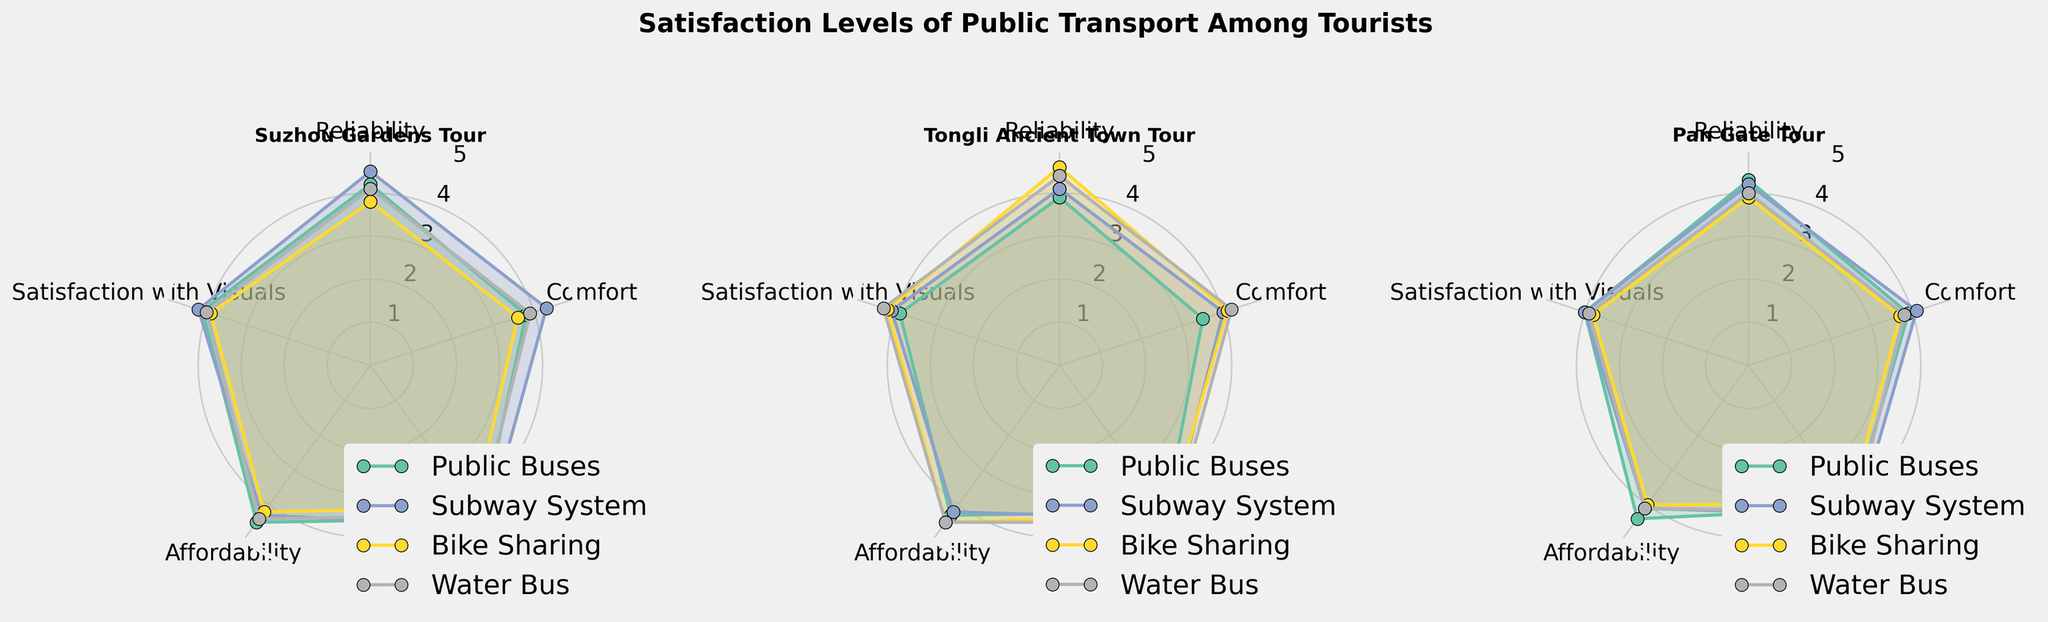What's the title of the figure? The title is displayed at the top of the figure and reads "Satisfaction Levels of Public Transport Among Tourists".
Answer: Satisfaction Levels of Public Transport Among Tourists How many subplots are there and what do they represent? There are three subplots, each representing satisfaction levels for different tours: Suzhou Gardens Tour, Tongli Ancient Town Tour, and Pan Gate Tour.
Answer: Three subplots Which transport mode consistently has the highest satisfaction in the 'Accessibility' category? By looking at the 'Accessibility' ratings in each subplot, the Subway System is consistently rated highest for all tours.
Answer: Subway System Between the Suzhou Gardens Tour and Tongli Ancient Town Tour, which has higher overall satisfaction for 'Water Bus'? Checking the water bus satisfaction values from the subplots for Suzhou Gardens Tour (4.3) and Tongli Ancient Town Tour (4.5), Tongli Ancient Town Tour is higher.
Answer: Tongli Ancient Town Tour What is the lowest satisfaction score across all categories for Pan Gate Tour? By examining all values for Pan Gate Tour, the lowest satisfaction score is for 'Bike Sharing' in 'Satisfaction with Visuals', which is 3.8.
Answer: 3.8 Rank the tours from highest to lowest based on 'Affordability' overall satisfaction. Looking at the overall satisfaction for 'Affordability': Tongli Ancient Town Tour (4.38), Suzhou Gardens Tour (4.35), and Pan Gate Tour (4.15).
Answer: Tongli Ancient Town Tour, Suzhou Gardens Tour, Pan Gate Tour How does 'Bike Sharing' satisfaction in 'Comfort' compare between Suzhou Gardens Tour and Pan Gate Tour? For the 'Comfort' category, Suzhou Gardens Tour is 3.6 and Pan Gate Tour is 3.7, so Pan Gate Tour is slightly higher.
Answer: Pan Gate Tour is higher Which category shows the largest variation in satisfaction for Public Buses in Tongli Ancient Town Tour? By comparing the ratings of Public Buses across different categories for Tongli Ancient Town Tour, the largest variation is in 'Comfort' (3.5 to 4.3).
Answer: Comfort For the Suzhou Gardens Tour, which transport mode has the lowest satisfaction in 'Comfort'? From the 'Comfort' ratings for Suzhou Gardens Tour, Bike Sharing has the lowest satisfaction at 3.6.
Answer: Bike Sharing 